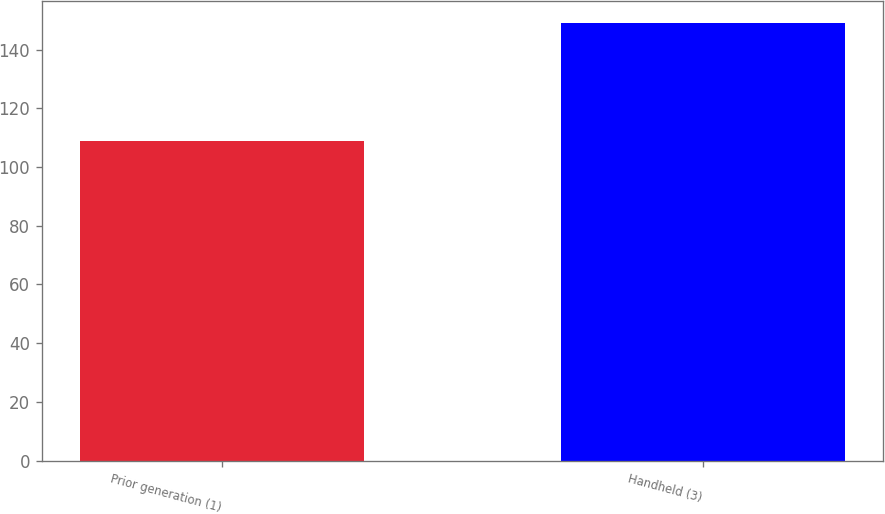<chart> <loc_0><loc_0><loc_500><loc_500><bar_chart><fcel>Prior generation (1)<fcel>Handheld (3)<nl><fcel>109<fcel>149<nl></chart> 